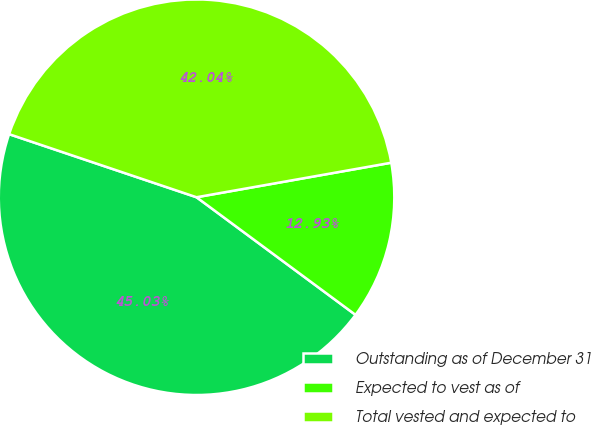Convert chart. <chart><loc_0><loc_0><loc_500><loc_500><pie_chart><fcel>Outstanding as of December 31<fcel>Expected to vest as of<fcel>Total vested and expected to<nl><fcel>45.03%<fcel>12.93%<fcel>42.04%<nl></chart> 